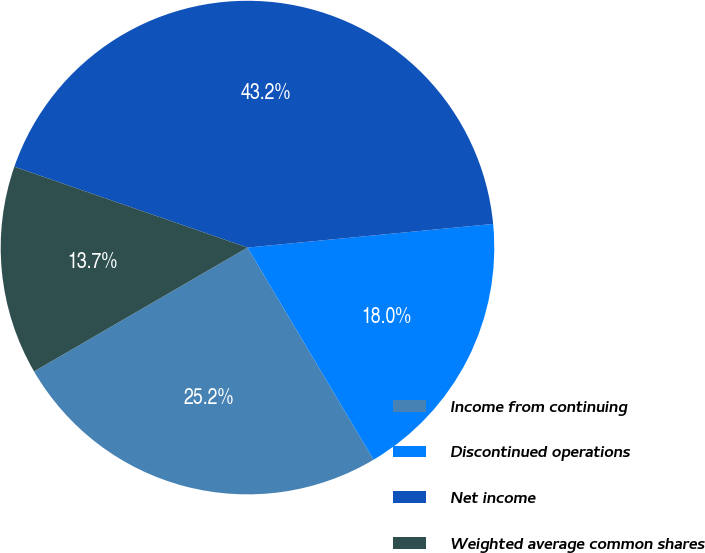Convert chart to OTSL. <chart><loc_0><loc_0><loc_500><loc_500><pie_chart><fcel>Income from continuing<fcel>Discontinued operations<fcel>Net income<fcel>Weighted average common shares<nl><fcel>25.17%<fcel>17.99%<fcel>43.16%<fcel>13.68%<nl></chart> 